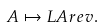<formula> <loc_0><loc_0><loc_500><loc_500>A \mapsto L A \L r e v .</formula> 